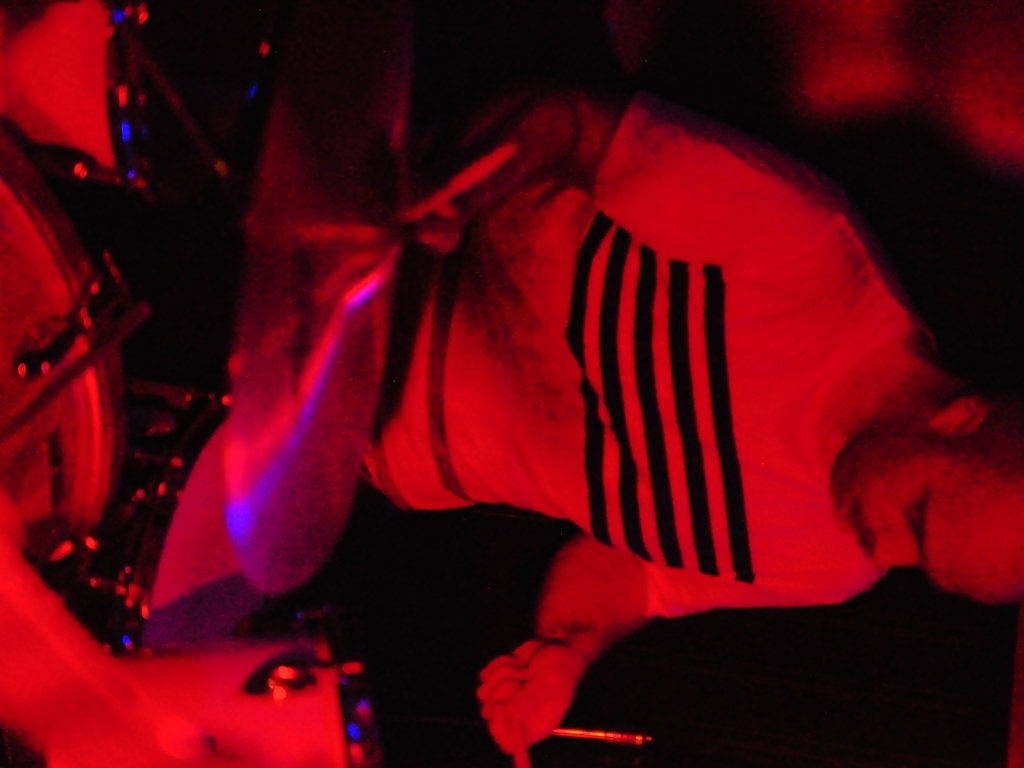What colors dominate the image? The image is dominated by red hues, suggesting a setting that may be dramatic or filled with energy, typical of concert lighting or a scene with a strong visual impact. 